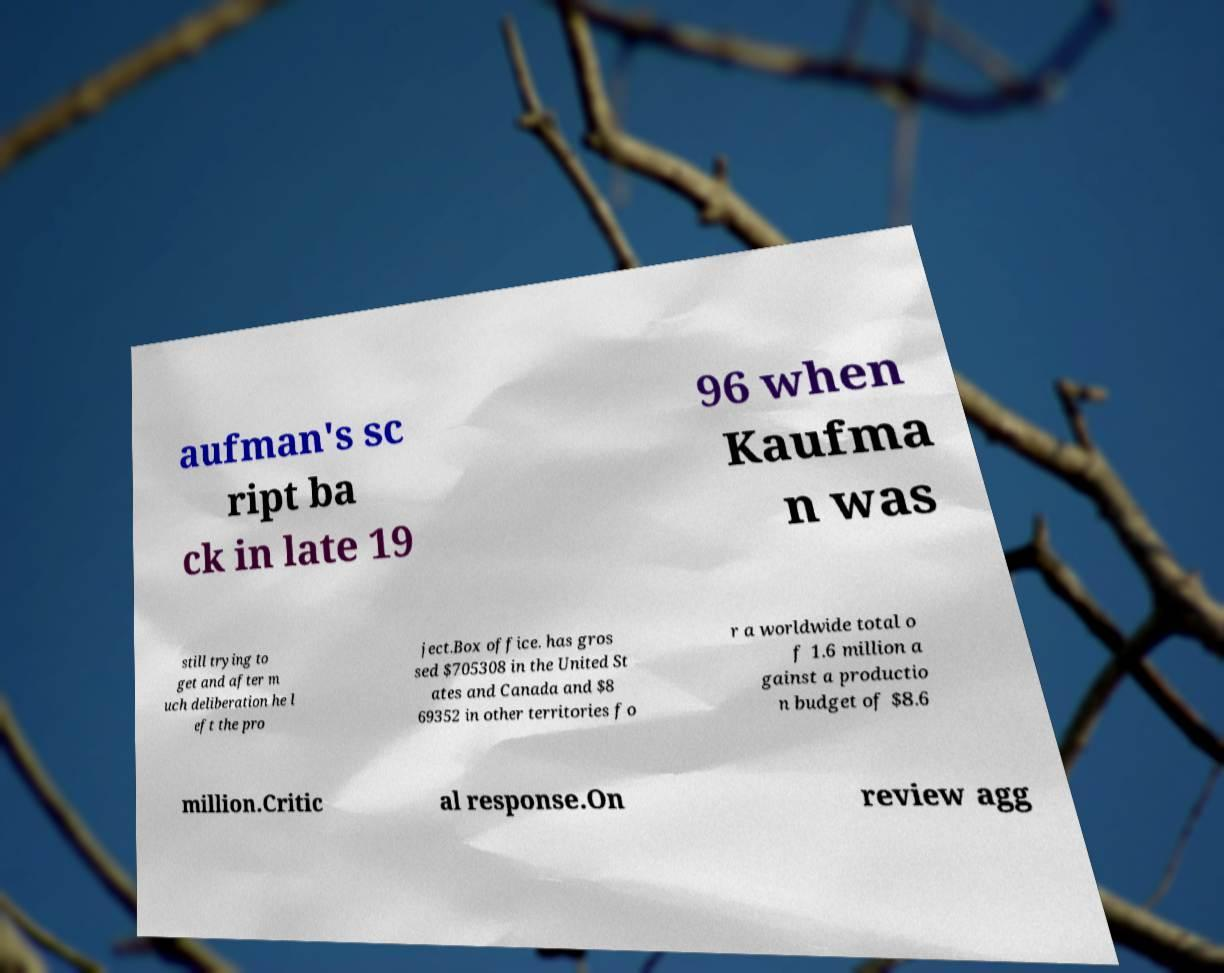Please read and relay the text visible in this image. What does it say? aufman's sc ript ba ck in late 19 96 when Kaufma n was still trying to get and after m uch deliberation he l eft the pro ject.Box office. has gros sed $705308 in the United St ates and Canada and $8 69352 in other territories fo r a worldwide total o f 1.6 million a gainst a productio n budget of $8.6 million.Critic al response.On review agg 